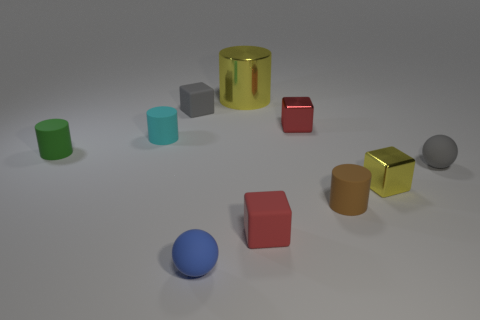Is there a pattern to the arrangement of these objects? The objects seem to be arranged randomly across the surface; however, there might be an underlying pattern based on color groups or pairs, like the golden cylinder and cube, but it doesn't extend to all objects. 